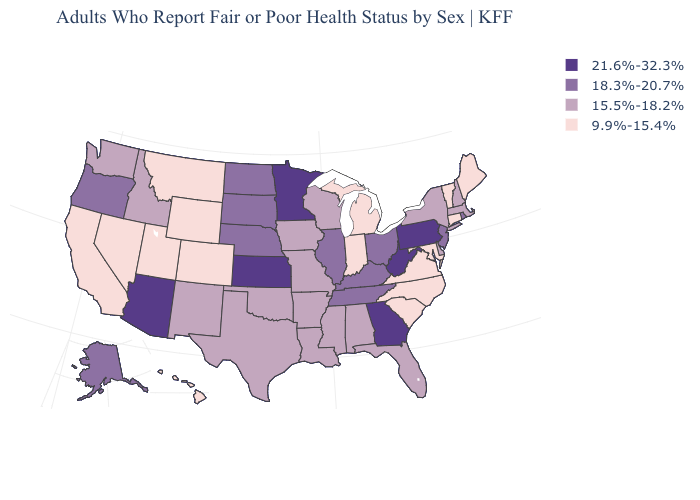Among the states that border Vermont , which have the lowest value?
Answer briefly. Massachusetts, New Hampshire, New York. Name the states that have a value in the range 18.3%-20.7%?
Give a very brief answer. Alaska, Illinois, Kentucky, Nebraska, New Jersey, North Dakota, Ohio, Oregon, Rhode Island, South Dakota, Tennessee. Among the states that border Kentucky , which have the lowest value?
Quick response, please. Indiana, Virginia. What is the value of West Virginia?
Give a very brief answer. 21.6%-32.3%. Name the states that have a value in the range 15.5%-18.2%?
Concise answer only. Alabama, Arkansas, Delaware, Florida, Idaho, Iowa, Louisiana, Massachusetts, Mississippi, Missouri, New Hampshire, New Mexico, New York, Oklahoma, Texas, Washington, Wisconsin. Does Indiana have the same value as Georgia?
Be succinct. No. Which states hav the highest value in the Northeast?
Answer briefly. Pennsylvania. What is the value of Utah?
Answer briefly. 9.9%-15.4%. Which states have the highest value in the USA?
Short answer required. Arizona, Georgia, Kansas, Minnesota, Pennsylvania, West Virginia. What is the value of Arizona?
Keep it brief. 21.6%-32.3%. Does the first symbol in the legend represent the smallest category?
Write a very short answer. No. Name the states that have a value in the range 21.6%-32.3%?
Give a very brief answer. Arizona, Georgia, Kansas, Minnesota, Pennsylvania, West Virginia. Does North Dakota have the lowest value in the USA?
Keep it brief. No. What is the value of Maine?
Concise answer only. 9.9%-15.4%. What is the highest value in the USA?
Keep it brief. 21.6%-32.3%. 